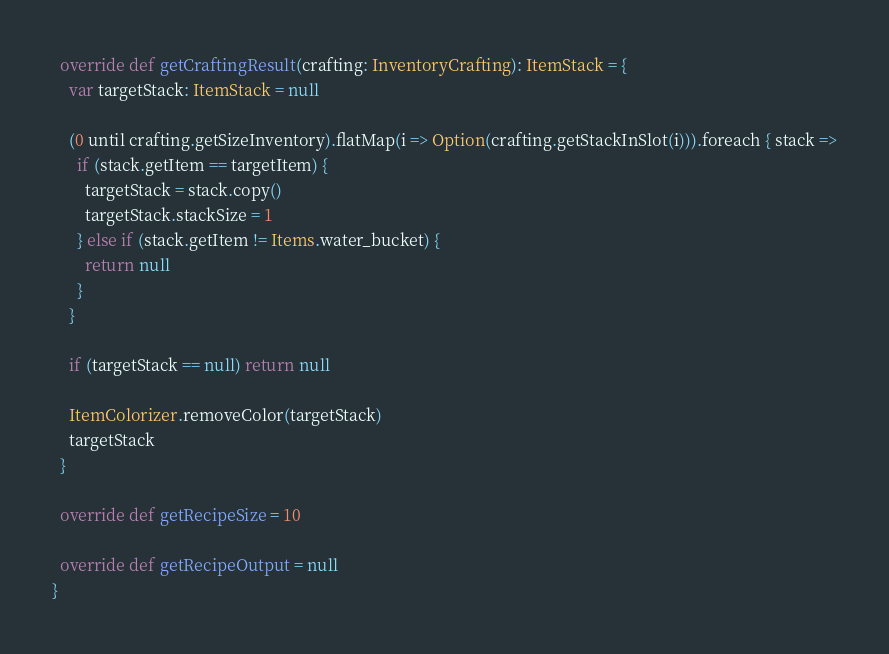Convert code to text. <code><loc_0><loc_0><loc_500><loc_500><_Scala_>
  override def getCraftingResult(crafting: InventoryCrafting): ItemStack = {
    var targetStack: ItemStack = null

    (0 until crafting.getSizeInventory).flatMap(i => Option(crafting.getStackInSlot(i))).foreach { stack =>
      if (stack.getItem == targetItem) {
        targetStack = stack.copy()
        targetStack.stackSize = 1
      } else if (stack.getItem != Items.water_bucket) {
        return null
      }
    }

    if (targetStack == null) return null

    ItemColorizer.removeColor(targetStack)
    targetStack
  }

  override def getRecipeSize = 10

  override def getRecipeOutput = null
}
</code> 